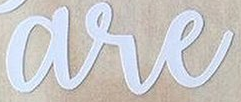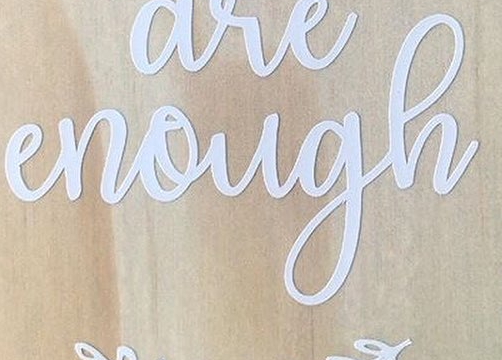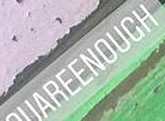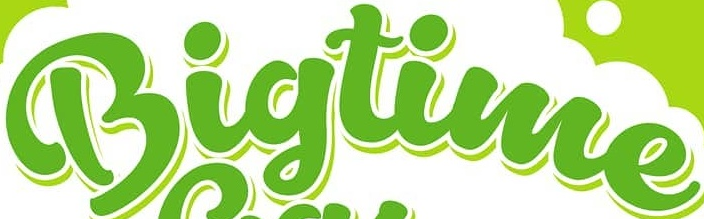Read the text content from these images in order, separated by a semicolon. are; enough; UAREENOUCH; Bigtime 